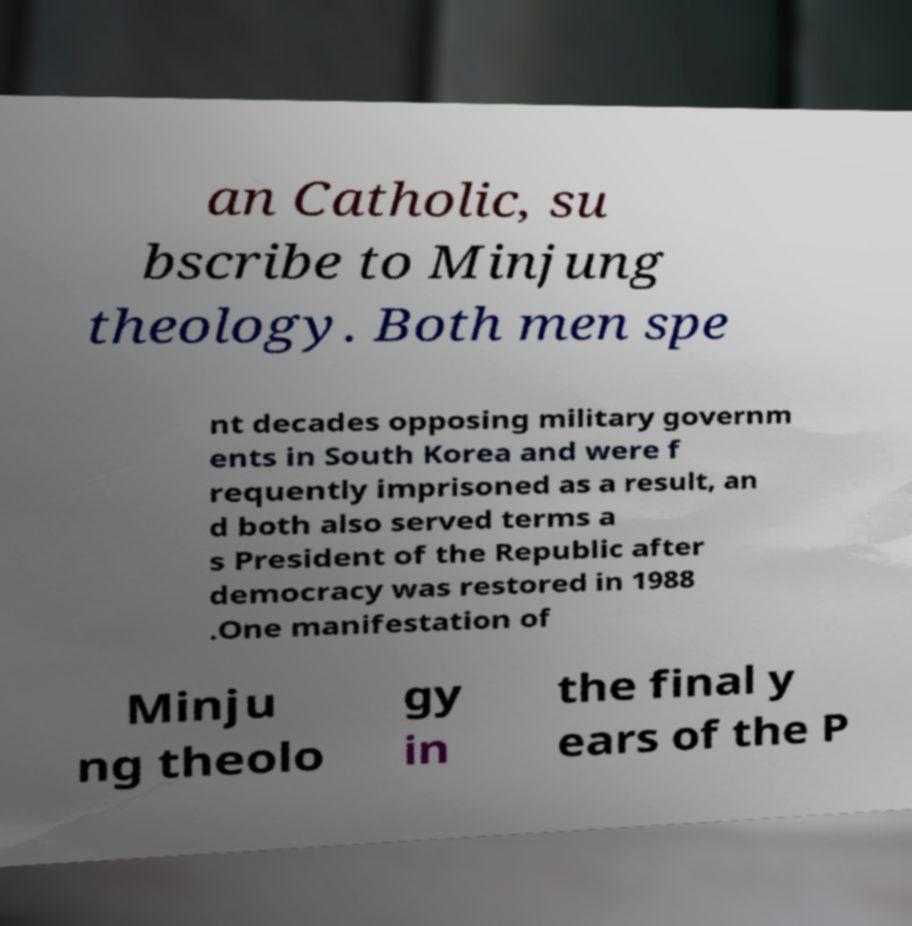Can you read and provide the text displayed in the image?This photo seems to have some interesting text. Can you extract and type it out for me? an Catholic, su bscribe to Minjung theology. Both men spe nt decades opposing military governm ents in South Korea and were f requently imprisoned as a result, an d both also served terms a s President of the Republic after democracy was restored in 1988 .One manifestation of Minju ng theolo gy in the final y ears of the P 